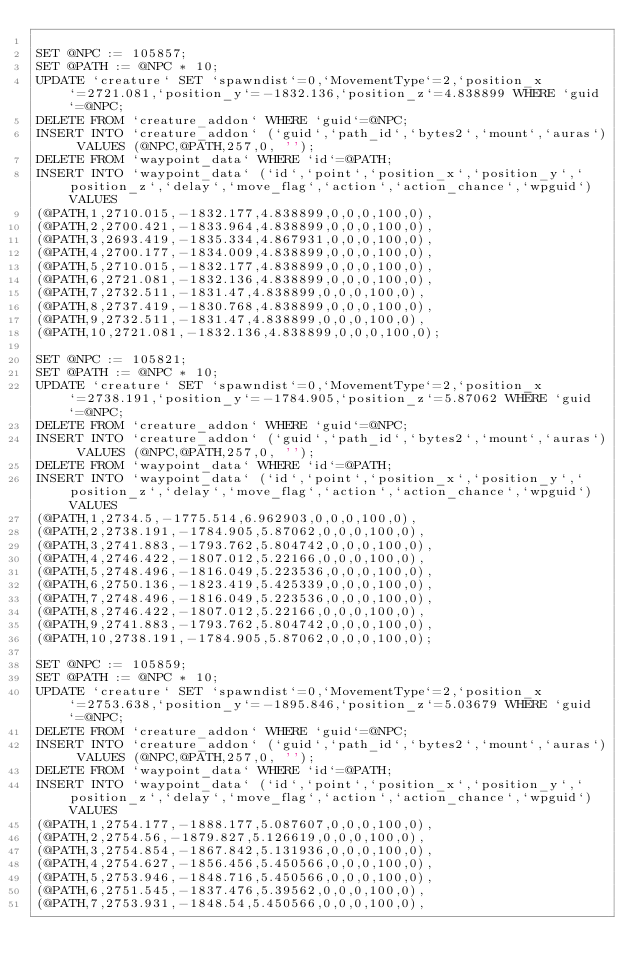<code> <loc_0><loc_0><loc_500><loc_500><_SQL_>
SET @NPC := 105857;
SET @PATH := @NPC * 10;
UPDATE `creature` SET `spawndist`=0,`MovementType`=2,`position_x`=2721.081,`position_y`=-1832.136,`position_z`=4.838899 WHERE `guid`=@NPC;
DELETE FROM `creature_addon` WHERE `guid`=@NPC;
INSERT INTO `creature_addon` (`guid`,`path_id`,`bytes2`,`mount`,`auras`) VALUES (@NPC,@PATH,257,0, '');
DELETE FROM `waypoint_data` WHERE `id`=@PATH;
INSERT INTO `waypoint_data` (`id`,`point`,`position_x`,`position_y`,`position_z`,`delay`,`move_flag`,`action`,`action_chance`,`wpguid`) VALUES
(@PATH,1,2710.015,-1832.177,4.838899,0,0,0,100,0),
(@PATH,2,2700.421,-1833.964,4.838899,0,0,0,100,0),
(@PATH,3,2693.419,-1835.334,4.867931,0,0,0,100,0),
(@PATH,4,2700.177,-1834.009,4.838899,0,0,0,100,0),
(@PATH,5,2710.015,-1832.177,4.838899,0,0,0,100,0),
(@PATH,6,2721.081,-1832.136,4.838899,0,0,0,100,0),
(@PATH,7,2732.511,-1831.47,4.838899,0,0,0,100,0),
(@PATH,8,2737.419,-1830.768,4.838899,0,0,0,100,0),
(@PATH,9,2732.511,-1831.47,4.838899,0,0,0,100,0),
(@PATH,10,2721.081,-1832.136,4.838899,0,0,0,100,0);

SET @NPC := 105821;
SET @PATH := @NPC * 10;
UPDATE `creature` SET `spawndist`=0,`MovementType`=2,`position_x`=2738.191,`position_y`=-1784.905,`position_z`=5.87062 WHERE `guid`=@NPC;
DELETE FROM `creature_addon` WHERE `guid`=@NPC;
INSERT INTO `creature_addon` (`guid`,`path_id`,`bytes2`,`mount`,`auras`) VALUES (@NPC,@PATH,257,0, '');
DELETE FROM `waypoint_data` WHERE `id`=@PATH;
INSERT INTO `waypoint_data` (`id`,`point`,`position_x`,`position_y`,`position_z`,`delay`,`move_flag`,`action`,`action_chance`,`wpguid`) VALUES
(@PATH,1,2734.5,-1775.514,6.962903,0,0,0,100,0),
(@PATH,2,2738.191,-1784.905,5.87062,0,0,0,100,0),
(@PATH,3,2741.883,-1793.762,5.804742,0,0,0,100,0),
(@PATH,4,2746.422,-1807.012,5.22166,0,0,0,100,0),
(@PATH,5,2748.496,-1816.049,5.223536,0,0,0,100,0),
(@PATH,6,2750.136,-1823.419,5.425339,0,0,0,100,0),
(@PATH,7,2748.496,-1816.049,5.223536,0,0,0,100,0),
(@PATH,8,2746.422,-1807.012,5.22166,0,0,0,100,0),
(@PATH,9,2741.883,-1793.762,5.804742,0,0,0,100,0),
(@PATH,10,2738.191,-1784.905,5.87062,0,0,0,100,0);

SET @NPC := 105859;
SET @PATH := @NPC * 10;
UPDATE `creature` SET `spawndist`=0,`MovementType`=2,`position_x`=2753.638,`position_y`=-1895.846,`position_z`=5.03679 WHERE `guid`=@NPC;
DELETE FROM `creature_addon` WHERE `guid`=@NPC;
INSERT INTO `creature_addon` (`guid`,`path_id`,`bytes2`,`mount`,`auras`) VALUES (@NPC,@PATH,257,0, '');
DELETE FROM `waypoint_data` WHERE `id`=@PATH;
INSERT INTO `waypoint_data` (`id`,`point`,`position_x`,`position_y`,`position_z`,`delay`,`move_flag`,`action`,`action_chance`,`wpguid`) VALUES
(@PATH,1,2754.177,-1888.177,5.087607,0,0,0,100,0),
(@PATH,2,2754.56,-1879.827,5.126619,0,0,0,100,0),
(@PATH,3,2754.854,-1867.842,5.131936,0,0,0,100,0),
(@PATH,4,2754.627,-1856.456,5.450566,0,0,0,100,0),
(@PATH,5,2753.946,-1848.716,5.450566,0,0,0,100,0),
(@PATH,6,2751.545,-1837.476,5.39562,0,0,0,100,0),
(@PATH,7,2753.931,-1848.54,5.450566,0,0,0,100,0),</code> 